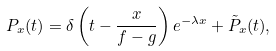<formula> <loc_0><loc_0><loc_500><loc_500>P _ { x } ( t ) = \delta \left ( t - \frac { x } { f - g } \right ) e ^ { - \lambda x } + \tilde { P } _ { x } ( t ) ,</formula> 